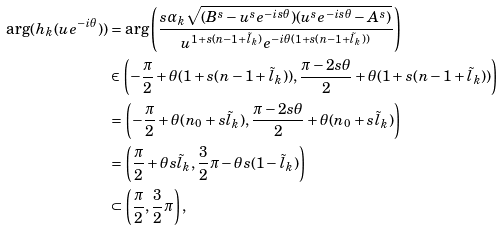Convert formula to latex. <formula><loc_0><loc_0><loc_500><loc_500>\arg ( h _ { k } ( u e ^ { - i \theta } ) ) & = \arg \left ( \frac { s \alpha _ { k } \sqrt { ( B ^ { s } - u ^ { s } e ^ { - i s \theta } ) ( u ^ { s } e ^ { - i s \theta } - A ^ { s } ) } } { u ^ { 1 + s ( n - 1 + \tilde { l } _ { k } ) } e ^ { - i \theta ( 1 + s ( n - 1 + \tilde { l } _ { k } ) ) } } \right ) \\ & \in \left ( - \frac { \pi } { 2 } + \theta ( 1 + s ( n - 1 + \tilde { l } _ { k } ) ) , \frac { \pi - 2 s \theta } { 2 } + \theta ( 1 + s ( n - 1 + \tilde { l } _ { k } ) ) \right ) \\ & = \left ( - \frac { \pi } { 2 } + \theta ( n _ { 0 } + s \tilde { l } _ { k } ) , \frac { \pi - 2 s \theta } { 2 } + \theta ( n _ { 0 } + s \tilde { l } _ { k } ) \right ) \\ & = \left ( \frac { \pi } { 2 } + \theta s \tilde { l } _ { k } , \frac { 3 } { 2 } \pi - \theta s ( 1 - \tilde { l } _ { k } ) \right ) \\ & \subset \left ( \frac { \pi } { 2 } , \frac { 3 } { 2 } \pi \right ) ,</formula> 